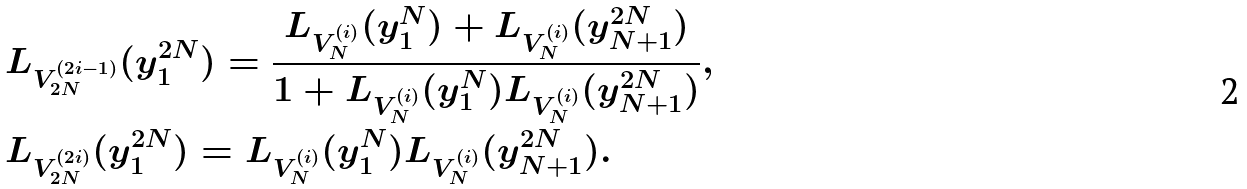<formula> <loc_0><loc_0><loc_500><loc_500>& L _ { V _ { 2 N } ^ { ( 2 i - 1 ) } } ( y _ { 1 } ^ { 2 N } ) = \frac { L _ { V _ { N } ^ { ( i ) } } ( y _ { 1 } ^ { N } ) + L _ { V _ { N } ^ { ( i ) } } ( y _ { N + 1 } ^ { 2 N } ) } { 1 + L _ { V _ { N } ^ { ( i ) } } ( y _ { 1 } ^ { N } ) L _ { V _ { N } ^ { ( i ) } } ( y _ { N + 1 } ^ { 2 N } ) } , \\ & L _ { V _ { 2 N } ^ { ( 2 i ) } } ( y _ { 1 } ^ { 2 N } ) = L _ { V _ { N } ^ { ( i ) } } ( y _ { 1 } ^ { N } ) L _ { V _ { N } ^ { ( i ) } } ( y _ { N + 1 } ^ { 2 N } ) .</formula> 